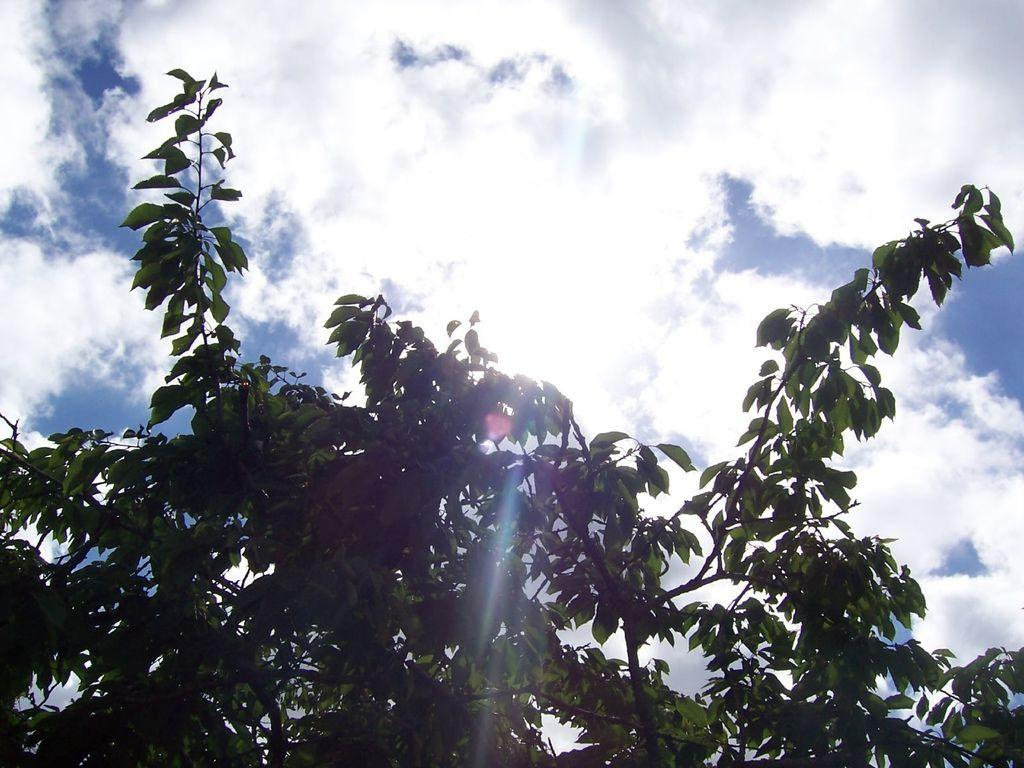What type of vegetation can be seen in the image? There are trees in the image. What is visible in the background of the image? The sky is visible in the background of the image. What can be observed in the sky? Clouds are present in the sky. What is the baby learning about the moon in the image? There is no baby or moon present in the image, so it is not possible to answer that question. 